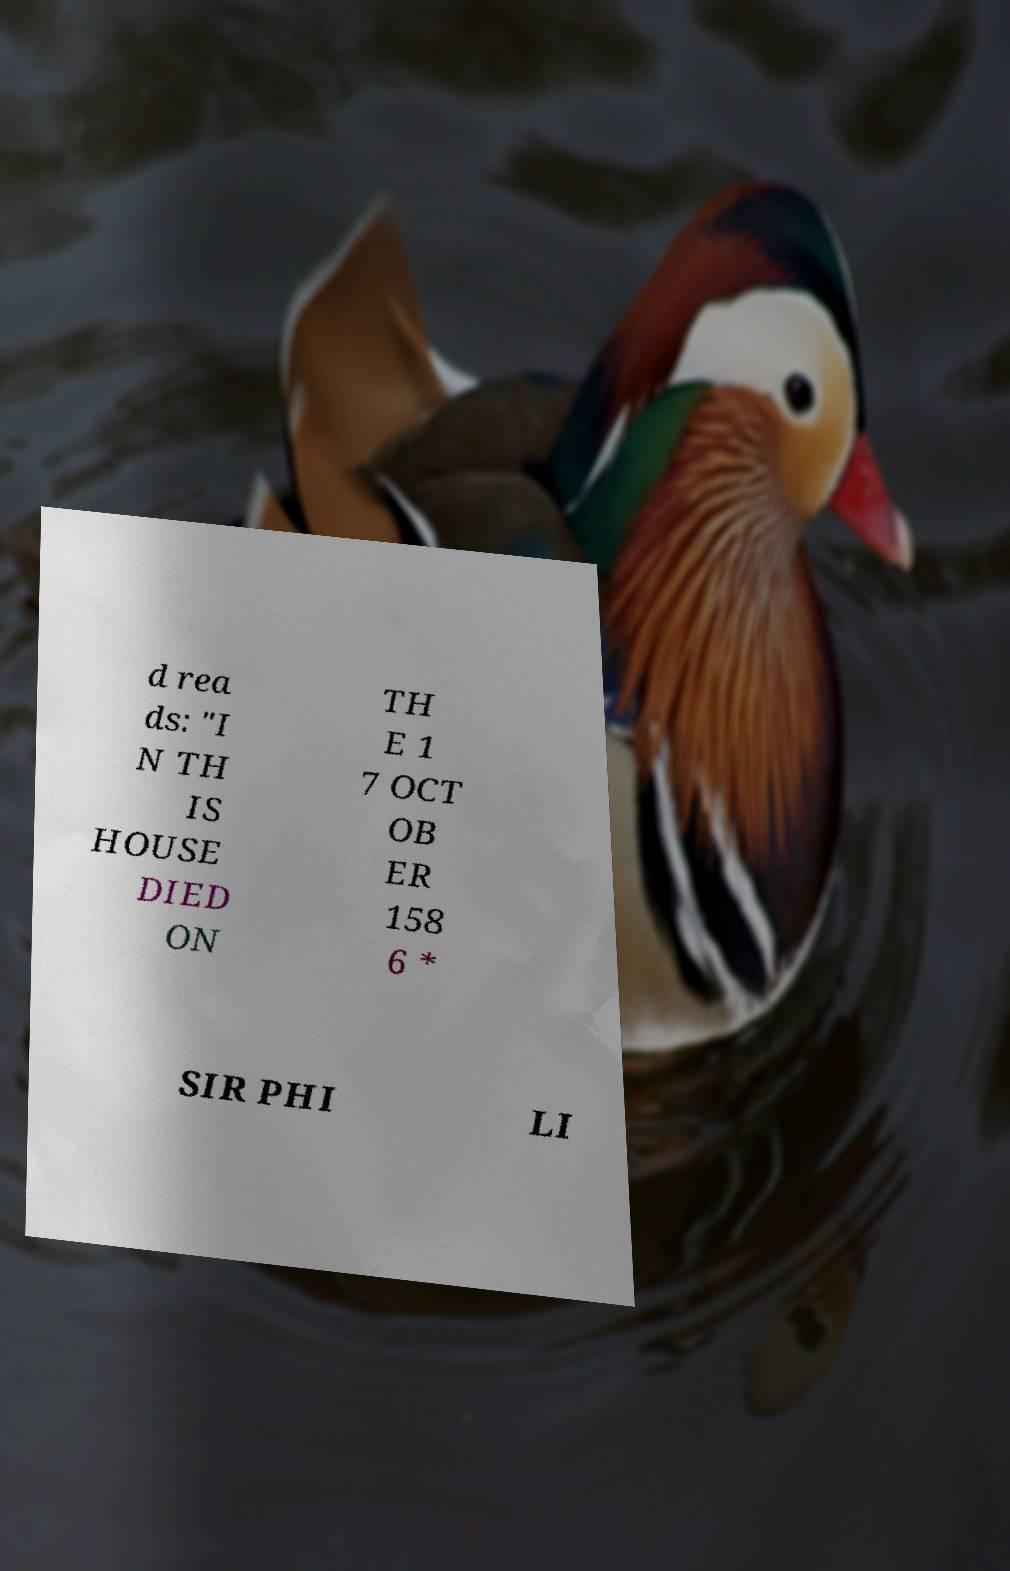What messages or text are displayed in this image? I need them in a readable, typed format. d rea ds: "I N TH IS HOUSE DIED ON TH E 1 7 OCT OB ER 158 6 * SIR PHI LI 